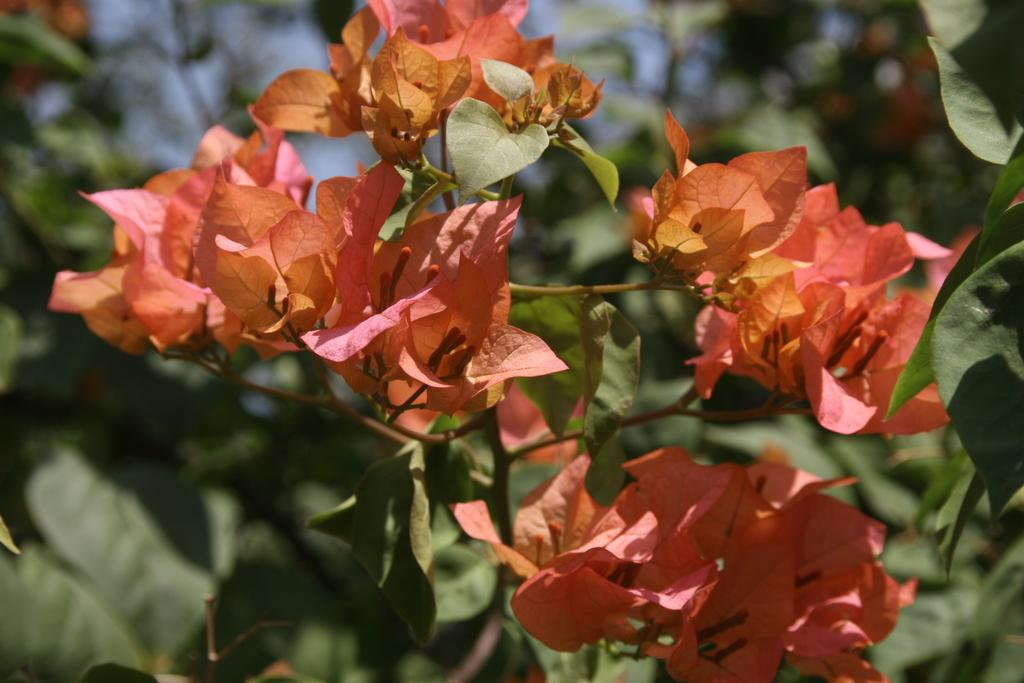What can be seen in the foreground of the picture? There are flowers, leaves, and stems in the foreground of the picture. How would you describe the appearance of the flowers? The flowers are colorful and appear to be in bloom. What is visible in the background of the picture? The background of the image is blurred, but there is a tree visible. What might be the reason for the blurred background? The blurred background could be due to a shallow depth of field, which is a technique used in photography to focus on a specific subject while blurring the background. What type of polish is being applied to the flowers in the image? There is no polish being applied to the flowers in the image; they are natural flowers in their original state. Can you see any cables or wires in the image? There are no cables or wires visible in the image. 